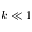Convert formula to latex. <formula><loc_0><loc_0><loc_500><loc_500>k \ll 1</formula> 